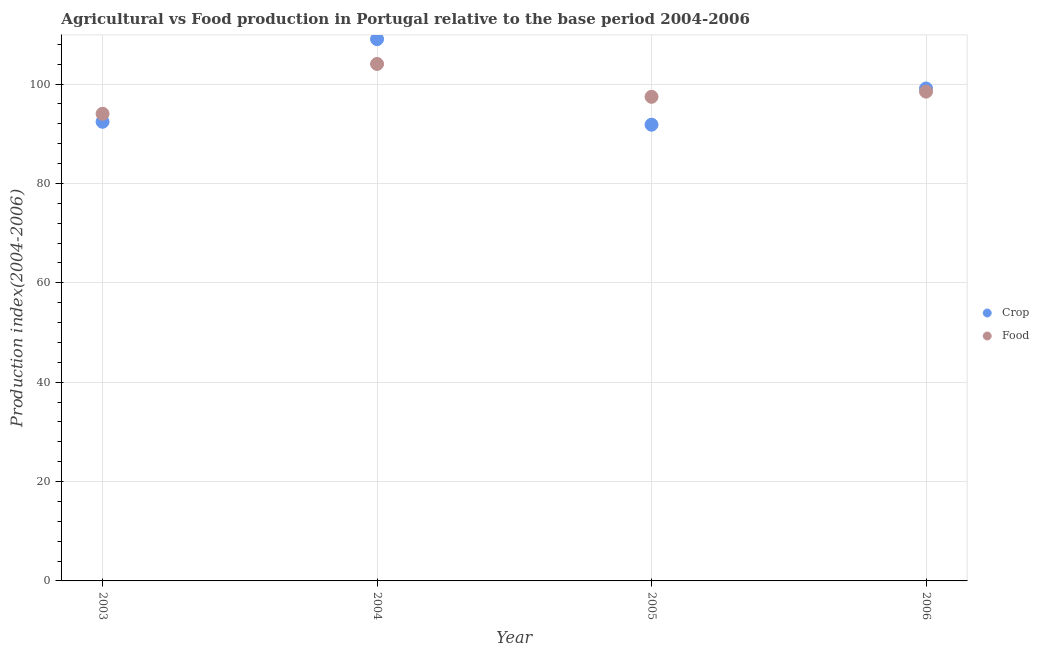Is the number of dotlines equal to the number of legend labels?
Ensure brevity in your answer.  Yes. What is the food production index in 2004?
Your answer should be very brief. 104.06. Across all years, what is the maximum food production index?
Give a very brief answer. 104.06. Across all years, what is the minimum food production index?
Give a very brief answer. 94.03. In which year was the food production index maximum?
Keep it short and to the point. 2004. What is the total food production index in the graph?
Make the answer very short. 394.02. What is the difference between the food production index in 2004 and that in 2005?
Provide a succinct answer. 6.62. What is the difference between the crop production index in 2003 and the food production index in 2004?
Offer a very short reply. -11.64. What is the average food production index per year?
Give a very brief answer. 98.5. In the year 2004, what is the difference between the food production index and crop production index?
Your response must be concise. -4.99. What is the ratio of the crop production index in 2004 to that in 2005?
Keep it short and to the point. 1.19. Is the crop production index in 2004 less than that in 2005?
Your response must be concise. No. What is the difference between the highest and the second highest crop production index?
Offer a very short reply. 9.93. What is the difference between the highest and the lowest food production index?
Your answer should be very brief. 10.03. In how many years, is the crop production index greater than the average crop production index taken over all years?
Provide a succinct answer. 2. Is the sum of the food production index in 2005 and 2006 greater than the maximum crop production index across all years?
Ensure brevity in your answer.  Yes. Is the crop production index strictly greater than the food production index over the years?
Make the answer very short. No. How many dotlines are there?
Provide a short and direct response. 2. What is the difference between two consecutive major ticks on the Y-axis?
Ensure brevity in your answer.  20. Are the values on the major ticks of Y-axis written in scientific E-notation?
Make the answer very short. No. Does the graph contain any zero values?
Offer a terse response. No. Does the graph contain grids?
Give a very brief answer. Yes. How are the legend labels stacked?
Offer a very short reply. Vertical. What is the title of the graph?
Make the answer very short. Agricultural vs Food production in Portugal relative to the base period 2004-2006. Does "Register a business" appear as one of the legend labels in the graph?
Offer a very short reply. No. What is the label or title of the X-axis?
Ensure brevity in your answer.  Year. What is the label or title of the Y-axis?
Your answer should be compact. Production index(2004-2006). What is the Production index(2004-2006) of Crop in 2003?
Your answer should be very brief. 92.42. What is the Production index(2004-2006) of Food in 2003?
Offer a very short reply. 94.03. What is the Production index(2004-2006) in Crop in 2004?
Your response must be concise. 109.05. What is the Production index(2004-2006) of Food in 2004?
Your answer should be compact. 104.06. What is the Production index(2004-2006) of Crop in 2005?
Keep it short and to the point. 91.83. What is the Production index(2004-2006) of Food in 2005?
Offer a very short reply. 97.44. What is the Production index(2004-2006) in Crop in 2006?
Your answer should be very brief. 99.12. What is the Production index(2004-2006) in Food in 2006?
Provide a succinct answer. 98.49. Across all years, what is the maximum Production index(2004-2006) of Crop?
Ensure brevity in your answer.  109.05. Across all years, what is the maximum Production index(2004-2006) in Food?
Your answer should be compact. 104.06. Across all years, what is the minimum Production index(2004-2006) of Crop?
Your answer should be compact. 91.83. Across all years, what is the minimum Production index(2004-2006) of Food?
Offer a very short reply. 94.03. What is the total Production index(2004-2006) in Crop in the graph?
Make the answer very short. 392.42. What is the total Production index(2004-2006) of Food in the graph?
Provide a short and direct response. 394.02. What is the difference between the Production index(2004-2006) in Crop in 2003 and that in 2004?
Make the answer very short. -16.63. What is the difference between the Production index(2004-2006) in Food in 2003 and that in 2004?
Your answer should be compact. -10.03. What is the difference between the Production index(2004-2006) in Crop in 2003 and that in 2005?
Your answer should be compact. 0.59. What is the difference between the Production index(2004-2006) of Food in 2003 and that in 2005?
Offer a terse response. -3.41. What is the difference between the Production index(2004-2006) of Food in 2003 and that in 2006?
Your answer should be very brief. -4.46. What is the difference between the Production index(2004-2006) in Crop in 2004 and that in 2005?
Give a very brief answer. 17.22. What is the difference between the Production index(2004-2006) in Food in 2004 and that in 2005?
Provide a short and direct response. 6.62. What is the difference between the Production index(2004-2006) of Crop in 2004 and that in 2006?
Your answer should be compact. 9.93. What is the difference between the Production index(2004-2006) in Food in 2004 and that in 2006?
Keep it short and to the point. 5.57. What is the difference between the Production index(2004-2006) of Crop in 2005 and that in 2006?
Keep it short and to the point. -7.29. What is the difference between the Production index(2004-2006) in Food in 2005 and that in 2006?
Offer a terse response. -1.05. What is the difference between the Production index(2004-2006) of Crop in 2003 and the Production index(2004-2006) of Food in 2004?
Your response must be concise. -11.64. What is the difference between the Production index(2004-2006) in Crop in 2003 and the Production index(2004-2006) in Food in 2005?
Give a very brief answer. -5.02. What is the difference between the Production index(2004-2006) of Crop in 2003 and the Production index(2004-2006) of Food in 2006?
Make the answer very short. -6.07. What is the difference between the Production index(2004-2006) in Crop in 2004 and the Production index(2004-2006) in Food in 2005?
Your response must be concise. 11.61. What is the difference between the Production index(2004-2006) in Crop in 2004 and the Production index(2004-2006) in Food in 2006?
Provide a succinct answer. 10.56. What is the difference between the Production index(2004-2006) of Crop in 2005 and the Production index(2004-2006) of Food in 2006?
Your answer should be very brief. -6.66. What is the average Production index(2004-2006) in Crop per year?
Offer a terse response. 98.11. What is the average Production index(2004-2006) in Food per year?
Your answer should be compact. 98.5. In the year 2003, what is the difference between the Production index(2004-2006) in Crop and Production index(2004-2006) in Food?
Offer a very short reply. -1.61. In the year 2004, what is the difference between the Production index(2004-2006) in Crop and Production index(2004-2006) in Food?
Offer a terse response. 4.99. In the year 2005, what is the difference between the Production index(2004-2006) in Crop and Production index(2004-2006) in Food?
Provide a short and direct response. -5.61. In the year 2006, what is the difference between the Production index(2004-2006) in Crop and Production index(2004-2006) in Food?
Ensure brevity in your answer.  0.63. What is the ratio of the Production index(2004-2006) in Crop in 2003 to that in 2004?
Your answer should be very brief. 0.85. What is the ratio of the Production index(2004-2006) of Food in 2003 to that in 2004?
Offer a very short reply. 0.9. What is the ratio of the Production index(2004-2006) in Crop in 2003 to that in 2005?
Your answer should be very brief. 1.01. What is the ratio of the Production index(2004-2006) of Food in 2003 to that in 2005?
Provide a short and direct response. 0.96. What is the ratio of the Production index(2004-2006) in Crop in 2003 to that in 2006?
Offer a terse response. 0.93. What is the ratio of the Production index(2004-2006) in Food in 2003 to that in 2006?
Offer a very short reply. 0.95. What is the ratio of the Production index(2004-2006) of Crop in 2004 to that in 2005?
Your answer should be very brief. 1.19. What is the ratio of the Production index(2004-2006) in Food in 2004 to that in 2005?
Your answer should be compact. 1.07. What is the ratio of the Production index(2004-2006) of Crop in 2004 to that in 2006?
Keep it short and to the point. 1.1. What is the ratio of the Production index(2004-2006) of Food in 2004 to that in 2006?
Your response must be concise. 1.06. What is the ratio of the Production index(2004-2006) in Crop in 2005 to that in 2006?
Ensure brevity in your answer.  0.93. What is the ratio of the Production index(2004-2006) in Food in 2005 to that in 2006?
Ensure brevity in your answer.  0.99. What is the difference between the highest and the second highest Production index(2004-2006) of Crop?
Your answer should be compact. 9.93. What is the difference between the highest and the second highest Production index(2004-2006) in Food?
Ensure brevity in your answer.  5.57. What is the difference between the highest and the lowest Production index(2004-2006) in Crop?
Provide a short and direct response. 17.22. What is the difference between the highest and the lowest Production index(2004-2006) in Food?
Your response must be concise. 10.03. 